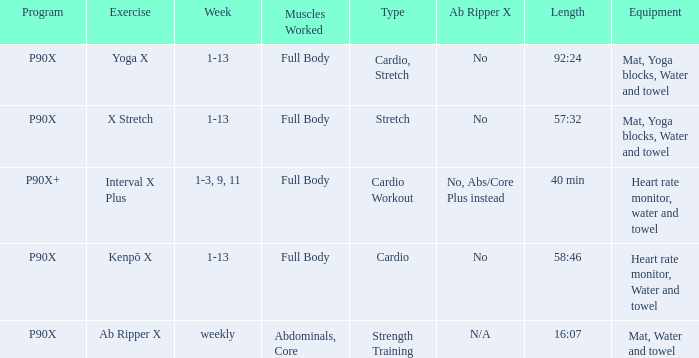What is the ab ripper x when exercise is x stretch? No. Could you help me parse every detail presented in this table? {'header': ['Program', 'Exercise', 'Week', 'Muscles Worked', 'Type', 'Ab Ripper X', 'Length', 'Equipment'], 'rows': [['P90X', 'Yoga X', '1-13', 'Full Body', 'Cardio, Stretch', 'No', '92:24', 'Mat, Yoga blocks, Water and towel'], ['P90X', 'X Stretch', '1-13', 'Full Body', 'Stretch', 'No', '57:32', 'Mat, Yoga blocks, Water and towel'], ['P90X+', 'Interval X Plus', '1-3, 9, 11', 'Full Body', 'Cardio Workout', 'No, Abs/Core Plus instead', '40 min', 'Heart rate monitor, water and towel'], ['P90X', 'Kenpō X', '1-13', 'Full Body', 'Cardio', 'No', '58:46', 'Heart rate monitor, Water and towel'], ['P90X', 'Ab Ripper X', 'weekly', 'Abdominals, Core', 'Strength Training', 'N/A', '16:07', 'Mat, Water and towel']]} 